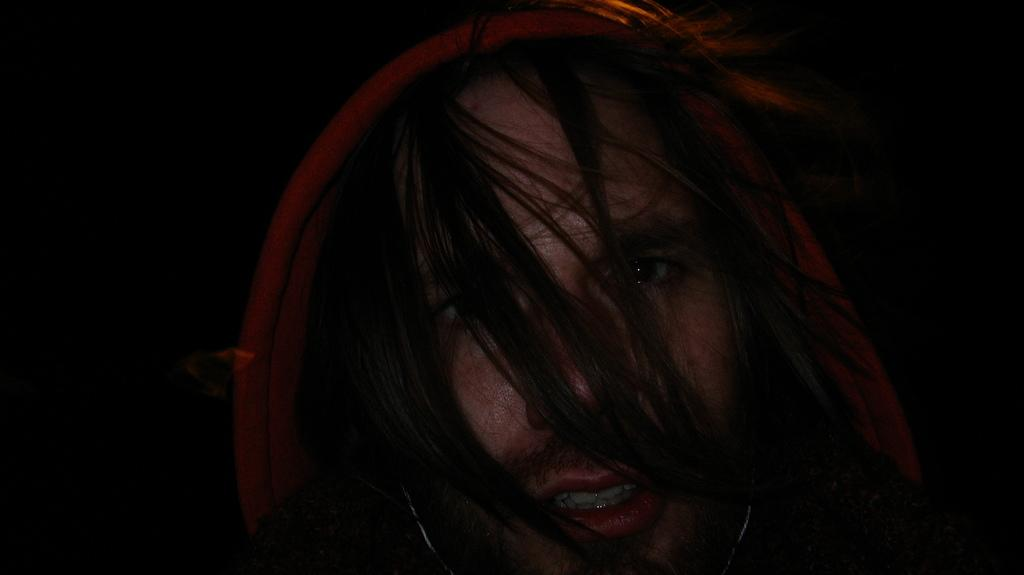What is the main subject of the image? The main subject of the image is a person's head. Can you describe the background of the image? The background of the image is dark. What type of plantation can be seen growing in the background of the image? There is no plantation present in the image; it only features a person's head with a dark background. What type of scale is visible on the person's head in the image? There is no scale visible on the person's head in the image. 